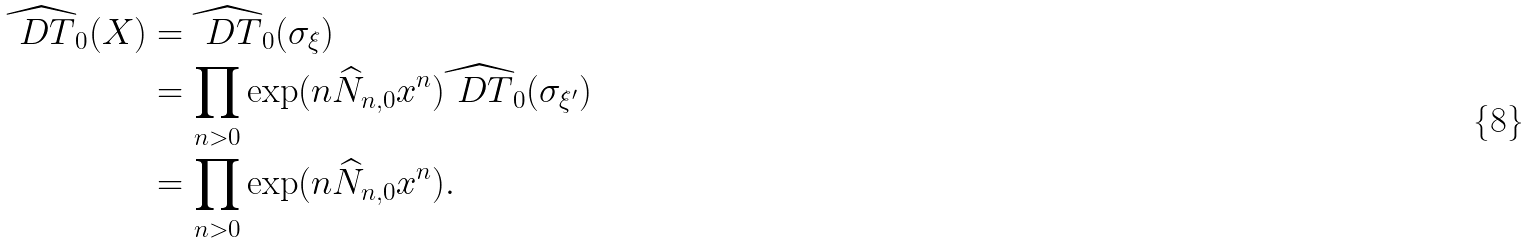Convert formula to latex. <formula><loc_0><loc_0><loc_500><loc_500>\widehat { \ D T } _ { 0 } ( X ) & = \widehat { \ D T } _ { 0 } ( \sigma _ { \xi } ) \\ & = \prod _ { n > 0 } \exp ( n \widehat { N } _ { n , 0 } x ^ { n } ) \widehat { \ D T } _ { 0 } ( \sigma _ { \xi ^ { \prime } } ) \\ & = \prod _ { n > 0 } \exp ( n \widehat { N } _ { n , 0 } x ^ { n } ) .</formula> 